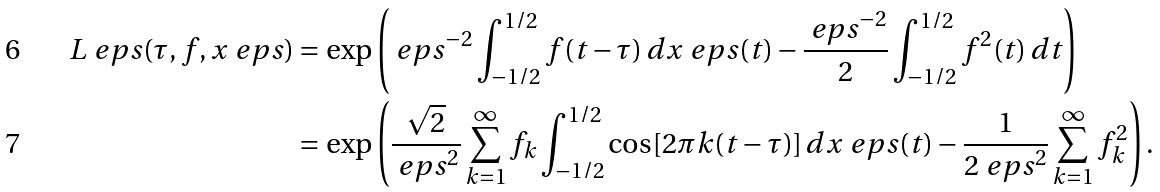Convert formula to latex. <formula><loc_0><loc_0><loc_500><loc_500>L _ { \ } e p s ( \tau , f , x ^ { \ } e p s ) & = \exp \left ( \ e p s ^ { - 2 } \int _ { - 1 / 2 } ^ { 1 / 2 } f ( t - \tau ) \, d x ^ { \ } e p s ( t ) - \frac { \ e p s ^ { - 2 } } { 2 } \int _ { - 1 / 2 } ^ { 1 / 2 } f ^ { 2 } ( t ) \, d t \right ) \\ & = \exp \left ( \frac { \sqrt { 2 } } { \ e p s ^ { 2 } } \sum _ { k = 1 } ^ { \infty } f _ { k } \int _ { - 1 / 2 } ^ { 1 / 2 } \cos [ 2 \pi k ( t - \tau ) ] \, d x ^ { \ } e p s ( t ) - \frac { 1 } { 2 \ e p s ^ { 2 } } \sum _ { k = 1 } ^ { \infty } f _ { k } ^ { 2 } \right ) .</formula> 